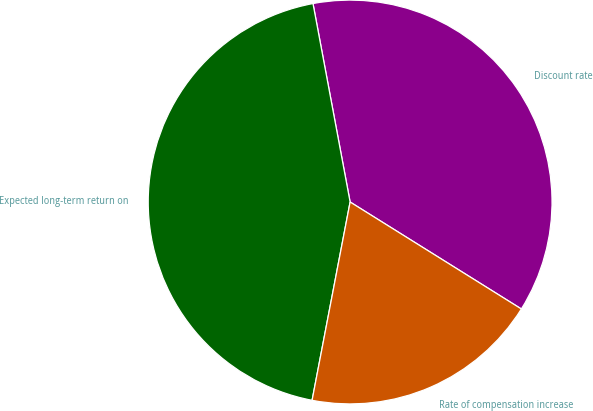Convert chart. <chart><loc_0><loc_0><loc_500><loc_500><pie_chart><fcel>Discount rate<fcel>Expected long-term return on<fcel>Rate of compensation increase<nl><fcel>36.83%<fcel>44.04%<fcel>19.13%<nl></chart> 